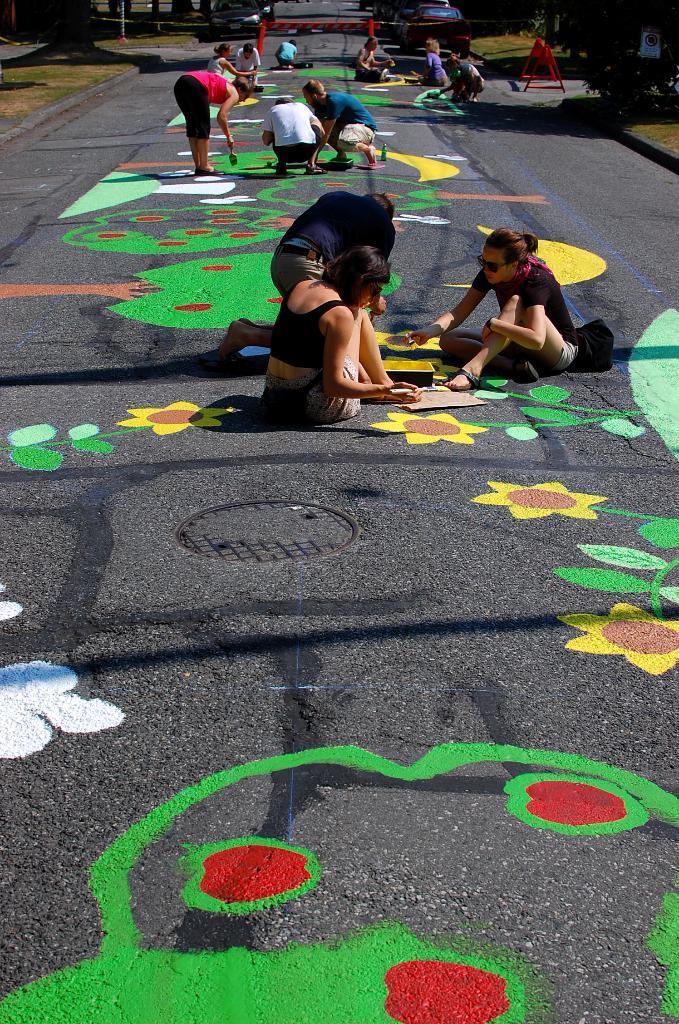Please provide a concise description of this image. Here I can see few people painting the flower designs on the road. On the road, I can see many paintings. In the background there are some trees beside the road. 